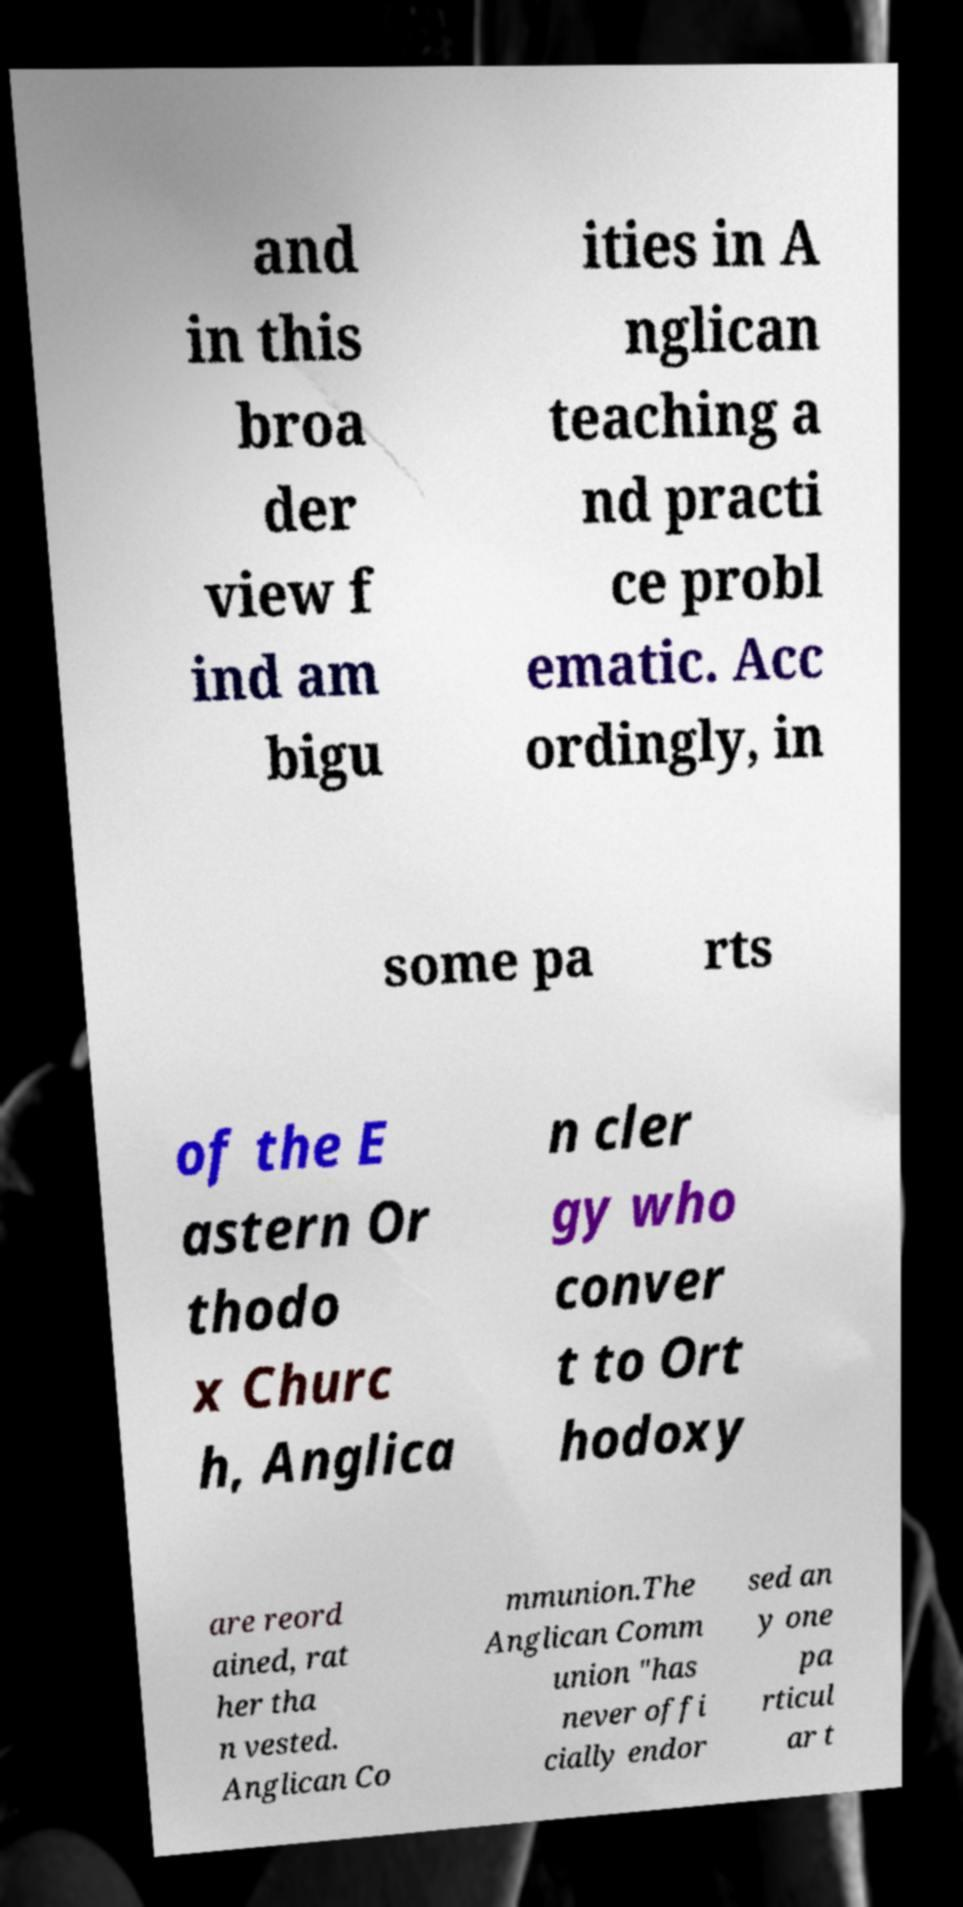Could you assist in decoding the text presented in this image and type it out clearly? and in this broa der view f ind am bigu ities in A nglican teaching a nd practi ce probl ematic. Acc ordingly, in some pa rts of the E astern Or thodo x Churc h, Anglica n cler gy who conver t to Ort hodoxy are reord ained, rat her tha n vested. Anglican Co mmunion.The Anglican Comm union "has never offi cially endor sed an y one pa rticul ar t 